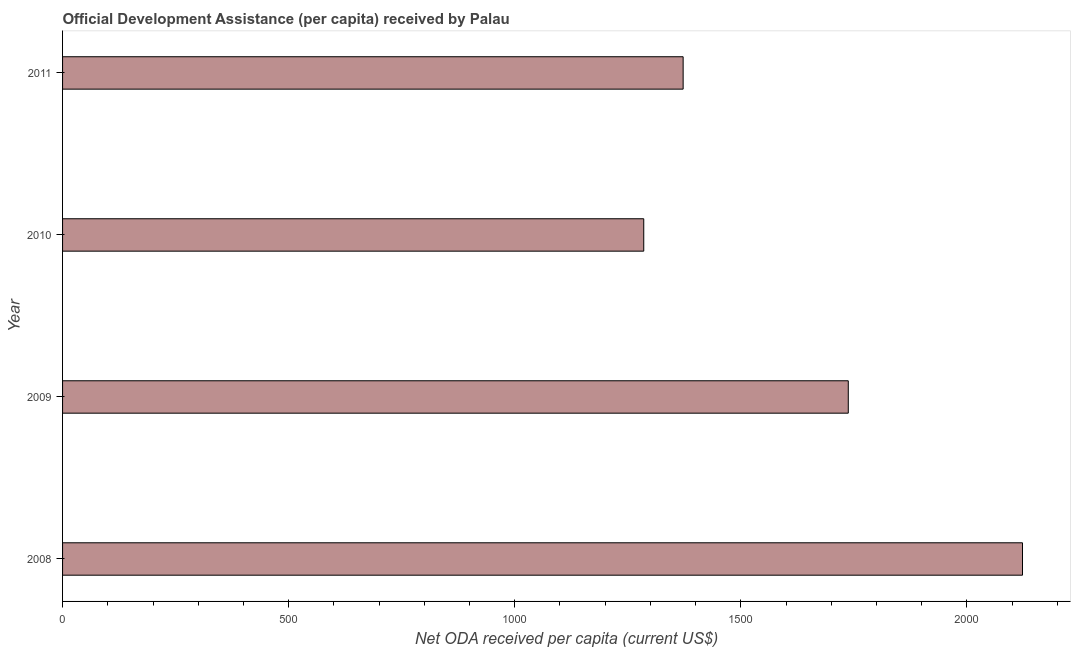Does the graph contain any zero values?
Give a very brief answer. No. Does the graph contain grids?
Provide a succinct answer. No. What is the title of the graph?
Your response must be concise. Official Development Assistance (per capita) received by Palau. What is the label or title of the X-axis?
Provide a succinct answer. Net ODA received per capita (current US$). What is the net oda received per capita in 2011?
Give a very brief answer. 1372.42. Across all years, what is the maximum net oda received per capita?
Provide a short and direct response. 2122.91. Across all years, what is the minimum net oda received per capita?
Ensure brevity in your answer.  1285.3. In which year was the net oda received per capita maximum?
Offer a terse response. 2008. What is the sum of the net oda received per capita?
Provide a short and direct response. 6518.23. What is the difference between the net oda received per capita in 2008 and 2011?
Your answer should be compact. 750.49. What is the average net oda received per capita per year?
Your answer should be compact. 1629.56. What is the median net oda received per capita?
Make the answer very short. 1555.01. What is the ratio of the net oda received per capita in 2008 to that in 2011?
Your answer should be compact. 1.55. Is the difference between the net oda received per capita in 2008 and 2009 greater than the difference between any two years?
Keep it short and to the point. No. What is the difference between the highest and the second highest net oda received per capita?
Your response must be concise. 385.29. Is the sum of the net oda received per capita in 2009 and 2010 greater than the maximum net oda received per capita across all years?
Keep it short and to the point. Yes. What is the difference between the highest and the lowest net oda received per capita?
Provide a succinct answer. 837.61. In how many years, is the net oda received per capita greater than the average net oda received per capita taken over all years?
Make the answer very short. 2. How many bars are there?
Ensure brevity in your answer.  4. Are all the bars in the graph horizontal?
Your response must be concise. Yes. How many years are there in the graph?
Your answer should be very brief. 4. What is the difference between two consecutive major ticks on the X-axis?
Your answer should be very brief. 500. Are the values on the major ticks of X-axis written in scientific E-notation?
Keep it short and to the point. No. What is the Net ODA received per capita (current US$) in 2008?
Your answer should be compact. 2122.91. What is the Net ODA received per capita (current US$) of 2009?
Your answer should be very brief. 1737.61. What is the Net ODA received per capita (current US$) in 2010?
Your answer should be very brief. 1285.3. What is the Net ODA received per capita (current US$) in 2011?
Your answer should be very brief. 1372.42. What is the difference between the Net ODA received per capita (current US$) in 2008 and 2009?
Offer a terse response. 385.29. What is the difference between the Net ODA received per capita (current US$) in 2008 and 2010?
Your answer should be very brief. 837.61. What is the difference between the Net ODA received per capita (current US$) in 2008 and 2011?
Your response must be concise. 750.49. What is the difference between the Net ODA received per capita (current US$) in 2009 and 2010?
Offer a very short reply. 452.32. What is the difference between the Net ODA received per capita (current US$) in 2009 and 2011?
Make the answer very short. 365.2. What is the difference between the Net ODA received per capita (current US$) in 2010 and 2011?
Your answer should be compact. -87.12. What is the ratio of the Net ODA received per capita (current US$) in 2008 to that in 2009?
Offer a terse response. 1.22. What is the ratio of the Net ODA received per capita (current US$) in 2008 to that in 2010?
Offer a very short reply. 1.65. What is the ratio of the Net ODA received per capita (current US$) in 2008 to that in 2011?
Keep it short and to the point. 1.55. What is the ratio of the Net ODA received per capita (current US$) in 2009 to that in 2010?
Ensure brevity in your answer.  1.35. What is the ratio of the Net ODA received per capita (current US$) in 2009 to that in 2011?
Give a very brief answer. 1.27. What is the ratio of the Net ODA received per capita (current US$) in 2010 to that in 2011?
Provide a short and direct response. 0.94. 